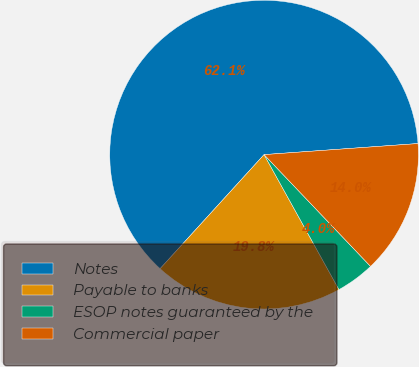Convert chart to OTSL. <chart><loc_0><loc_0><loc_500><loc_500><pie_chart><fcel>Notes<fcel>Payable to banks<fcel>ESOP notes guaranteed by the<fcel>Commercial paper<nl><fcel>62.1%<fcel>19.83%<fcel>4.05%<fcel>14.03%<nl></chart> 